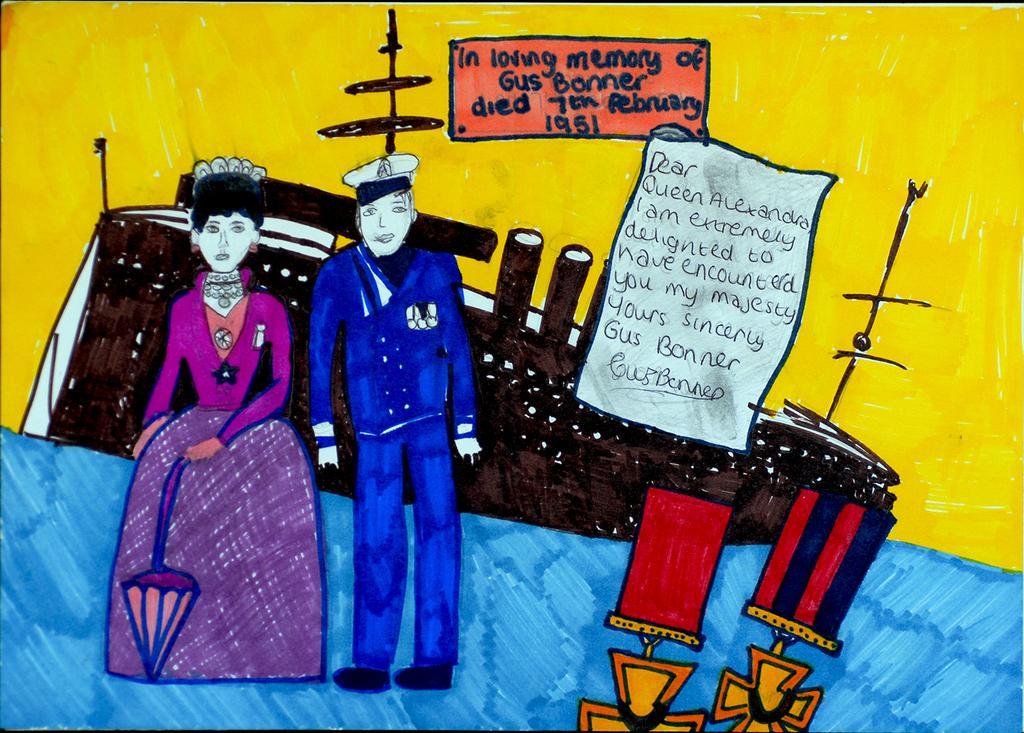How would you summarize this image in a sentence or two? In this image I can see two people are standing. Back I can see the boat, something is written on the papers and color objects. I can see a blue and yellow background. 